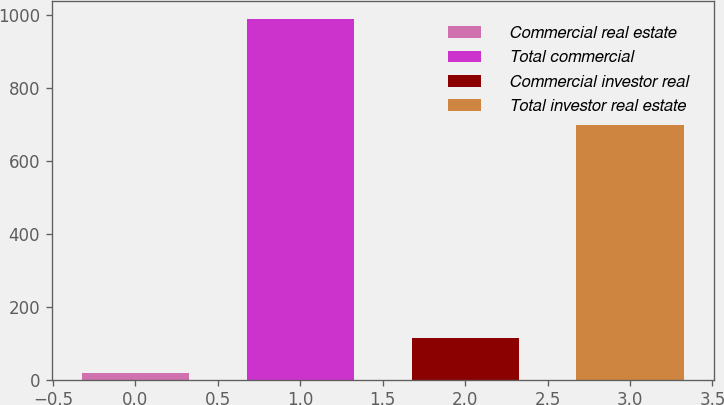<chart> <loc_0><loc_0><loc_500><loc_500><bar_chart><fcel>Commercial real estate<fcel>Total commercial<fcel>Commercial investor real<fcel>Total investor real estate<nl><fcel>18<fcel>988<fcel>115<fcel>697<nl></chart> 